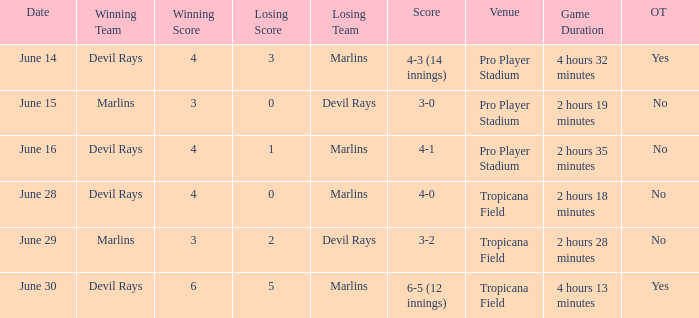Who won by a score of 4-1? Devil Rays. 